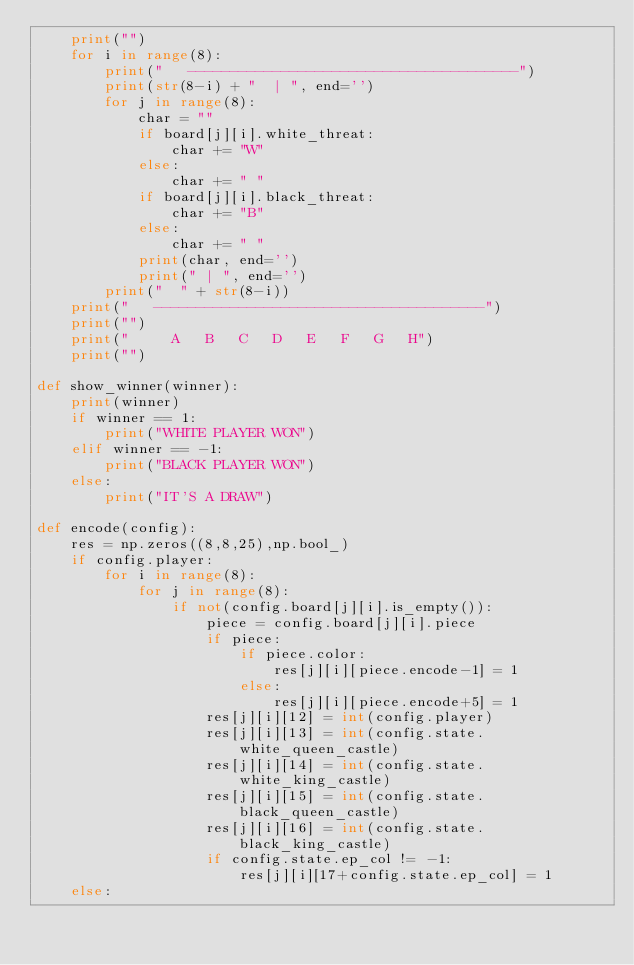<code> <loc_0><loc_0><loc_500><loc_500><_Python_>    print("")
    for i in range(8):
        print("   ---------------------------------------")
        print(str(8-i) + "  | ", end='')
        for j in range(8):
            char = ""
            if board[j][i].white_threat:
                char += "W"
            else:
                char += " "
            if board[j][i].black_threat:
                char += "B"
            else:
                char += " "
            print(char, end='')
            print(" | ", end='')
        print("  " + str(8-i))
    print("   ---------------------------------------")
    print("")
    print("     A   B   C   D   E   F   G   H")
    print("")

def show_winner(winner):
    print(winner)
    if winner == 1:
        print("WHITE PLAYER WON")
    elif winner == -1:
        print("BLACK PLAYER WON")
    else:
        print("IT'S A DRAW")

def encode(config):
    res = np.zeros((8,8,25),np.bool_)
    if config.player:
        for i in range(8):
            for j in range(8):
                if not(config.board[j][i].is_empty()):
                    piece = config.board[j][i].piece
                    if piece:
                        if piece.color:
                            res[j][i][piece.encode-1] = 1
                        else:
                            res[j][i][piece.encode+5] = 1
                    res[j][i][12] = int(config.player)
                    res[j][i][13] = int(config.state.white_queen_castle)
                    res[j][i][14] = int(config.state.white_king_castle)
                    res[j][i][15] = int(config.state.black_queen_castle)
                    res[j][i][16] = int(config.state.black_king_castle)
                    if config.state.ep_col != -1:
                        res[j][i][17+config.state.ep_col] = 1
    else:</code> 